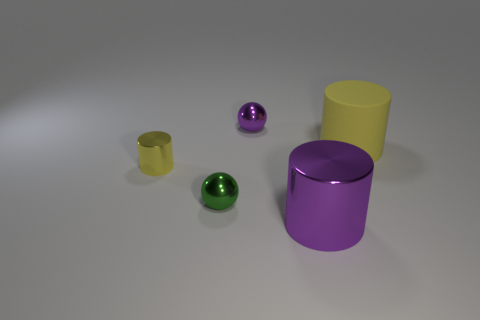What is the material of the other small cylinder that is the same color as the rubber cylinder?
Your response must be concise. Metal. Do the metallic object behind the large yellow rubber object and the large shiny object have the same color?
Your answer should be very brief. Yes. There is a large yellow matte cylinder that is in front of the purple metallic thing that is behind the purple metallic cylinder; how many green metallic spheres are on the right side of it?
Provide a short and direct response. 0. Are there fewer big rubber objects that are to the left of the green object than gray rubber things?
Your response must be concise. No. There is a purple thing that is behind the big yellow matte cylinder; what shape is it?
Keep it short and to the point. Sphere. There is a purple thing that is in front of the sphere that is in front of the sphere that is behind the small cylinder; what is its shape?
Provide a short and direct response. Cylinder. How many things are purple metal spheres or purple metal objects?
Give a very brief answer. 2. There is a purple shiny object behind the big yellow rubber cylinder; is its shape the same as the thing to the right of the big purple metal cylinder?
Your answer should be compact. No. What number of things are in front of the yellow metallic cylinder and behind the large yellow matte cylinder?
Provide a succinct answer. 0. What number of other objects are there of the same size as the purple cylinder?
Ensure brevity in your answer.  1. 